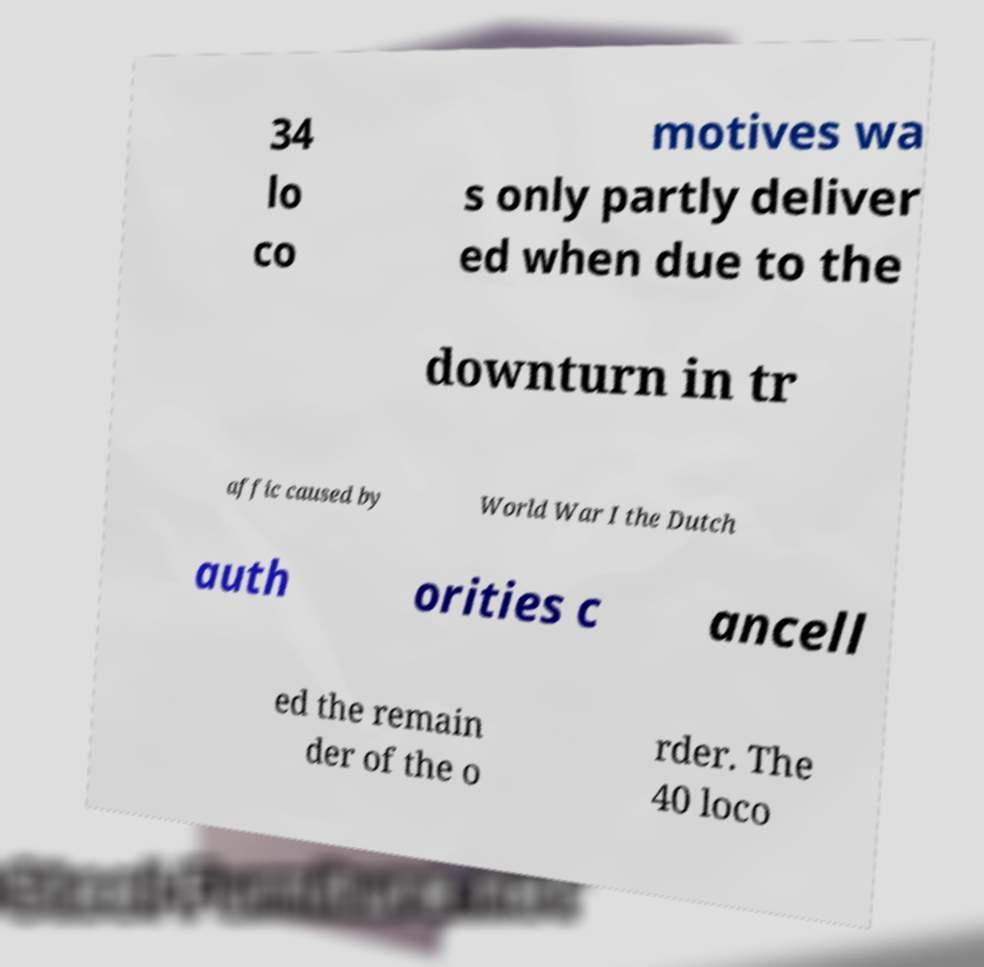Please identify and transcribe the text found in this image. 34 lo co motives wa s only partly deliver ed when due to the downturn in tr affic caused by World War I the Dutch auth orities c ancell ed the remain der of the o rder. The 40 loco 